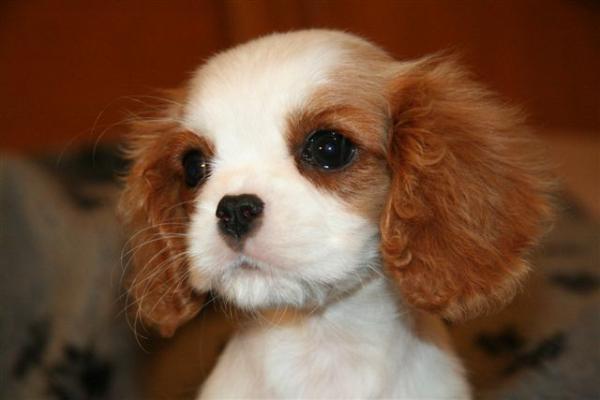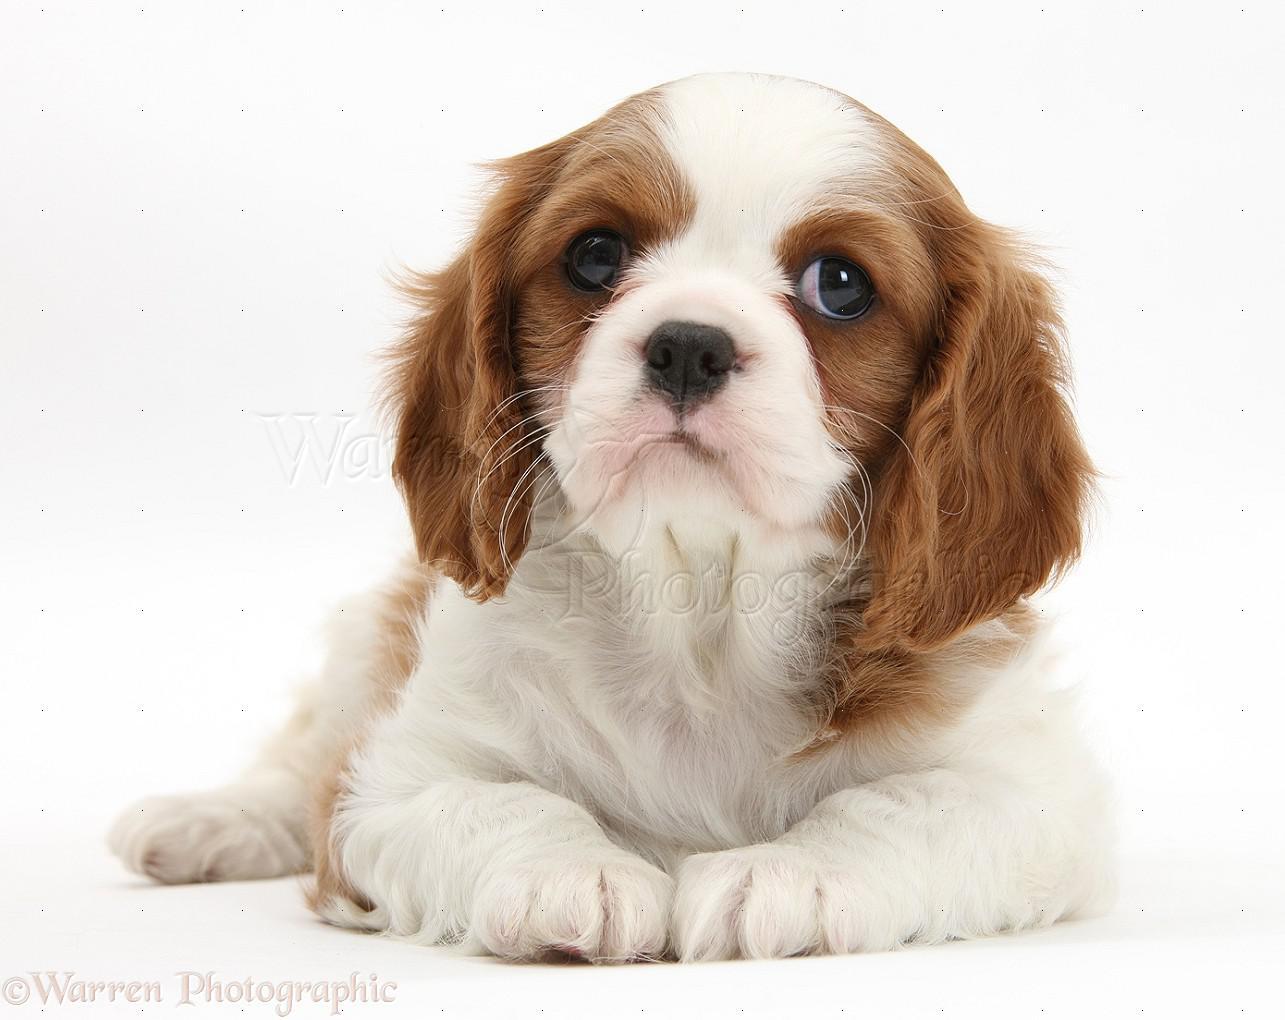The first image is the image on the left, the second image is the image on the right. Analyze the images presented: Is the assertion "An image shows a puppy on a tile floor." valid? Answer yes or no. No. 